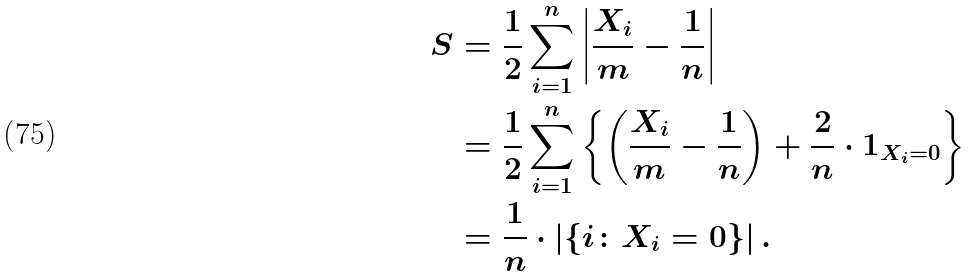Convert formula to latex. <formula><loc_0><loc_0><loc_500><loc_500>S & = \frac { 1 } { 2 } \sum _ { i = 1 } ^ { n } \left | \frac { X _ { i } } { m } - \frac { 1 } { n } \right | \\ & = \frac { 1 } { 2 } \sum _ { i = 1 } ^ { n } \left \{ \left ( \frac { X _ { i } } { m } - \frac { 1 } { n } \right ) + \frac { 2 } { n } \cdot 1 _ { X _ { i } = 0 } \right \} \\ & = \frac { 1 } { n } \cdot | \{ i \colon X _ { i } = 0 \} | \, .</formula> 